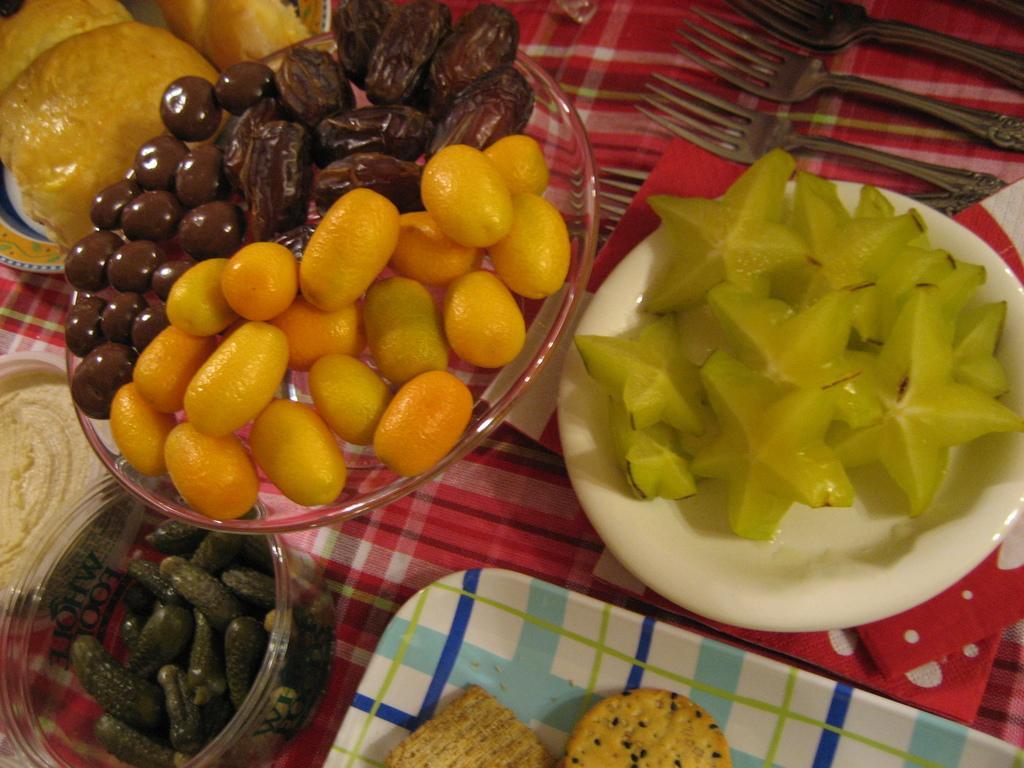Can you describe this image briefly? In this image there few varieties of food item are arranged in plates and bowls, there are a few forks placed on the table. 